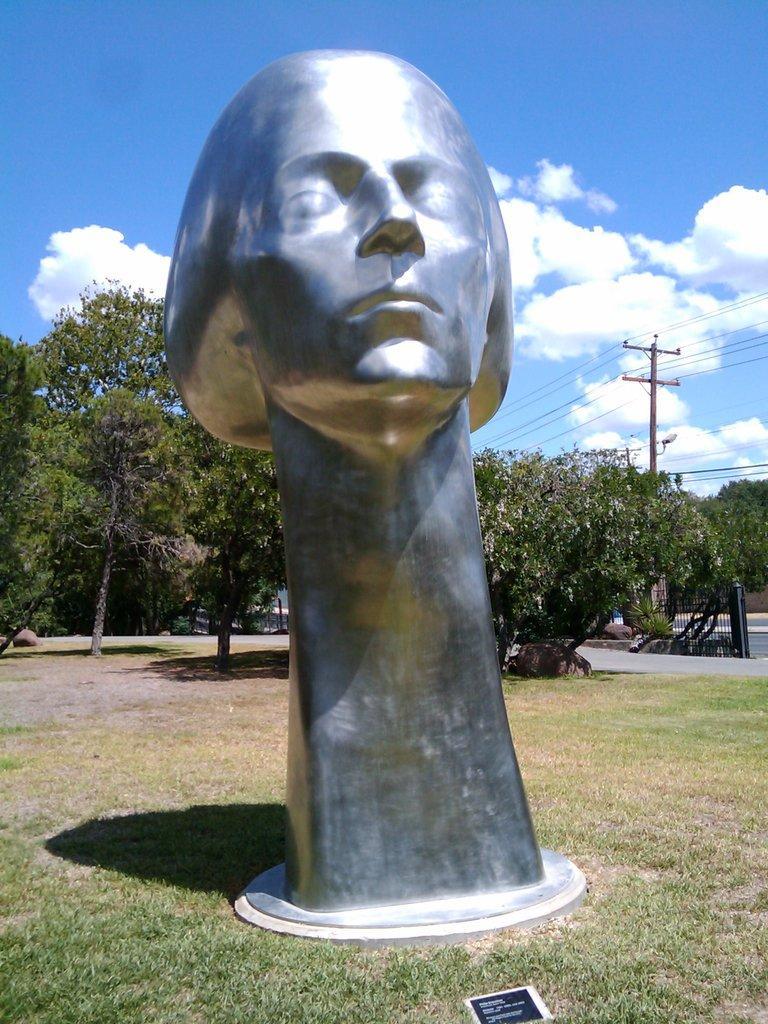Please provide a concise description of this image. In this image I can see in the middle there is the statue, at the back side there are trees, on the right side there is an electric pole. At the top it is the cloudy sky. 